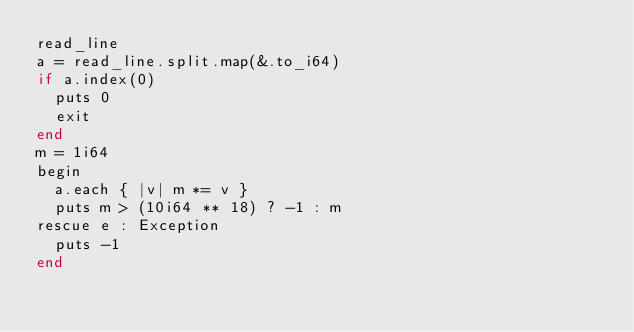<code> <loc_0><loc_0><loc_500><loc_500><_Crystal_>read_line
a = read_line.split.map(&.to_i64)
if a.index(0)
  puts 0
  exit
end
m = 1i64
begin
  a.each { |v| m *= v }
  puts m > (10i64 ** 18) ? -1 : m
rescue e : Exception
  puts -1
end
</code> 